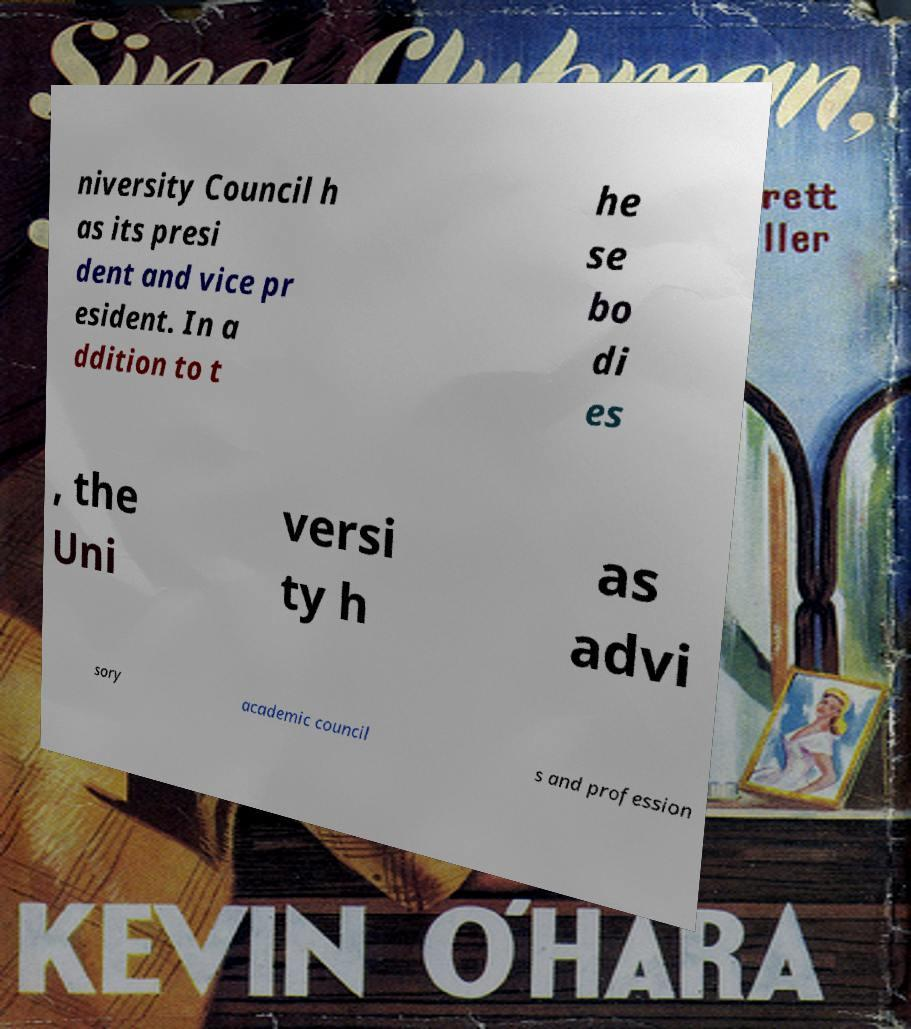What messages or text are displayed in this image? I need them in a readable, typed format. niversity Council h as its presi dent and vice pr esident. In a ddition to t he se bo di es , the Uni versi ty h as advi sory academic council s and profession 